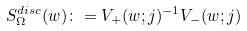Convert formula to latex. <formula><loc_0><loc_0><loc_500><loc_500>S _ { \Omega } ^ { d i s c } ( w ) \colon = V _ { + } ( w ; j ) ^ { - 1 } V _ { - } ( w ; j )</formula> 